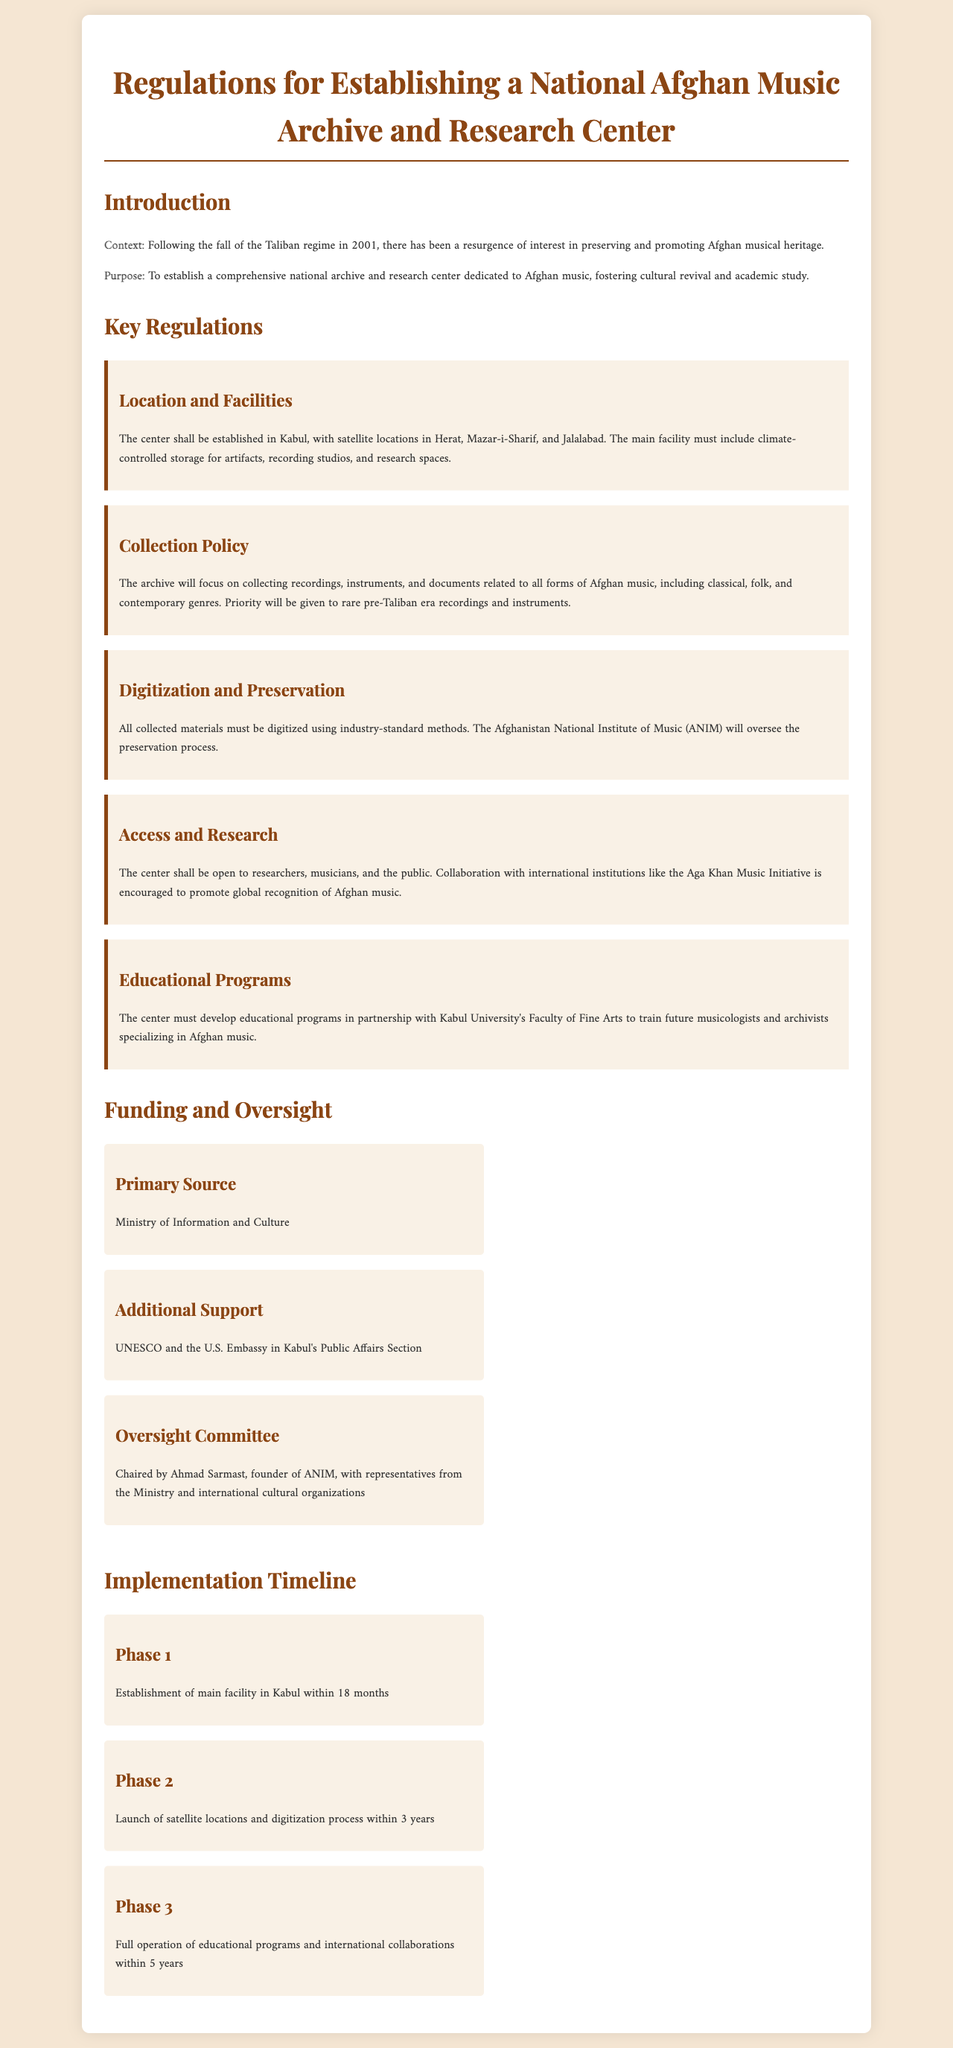What is the main location for the center? The main center will be established in Kabul, as stated in the key regulations section.
Answer: Kabul Which organization oversees the preservation process? The document specifies that the Afghanistan National Institute of Music (ANIM) will oversee preservation.
Answer: ANIM What is the priority for the collection policy? The document indicates that priority will be given to rare pre-Taliban era recordings and instruments.
Answer: Rare pre-Taliban era recordings and instruments Who is the chair of the oversight committee? The document clearly names Ahmad Sarmast as the chair of the oversight committee.
Answer: Ahmad Sarmast What is the time frame for establishing the main facility? The timeline section reveals that the main facility is to be established within 18 months.
Answer: 18 months Which entity is mentioned as a source of additional support? The document refers to UNESCO as one of the sources of additional support.
Answer: UNESCO What type of educational programs must the center develop? The educational programs must focus on training future musicologists and archivists specializing in Afghan music.
Answer: Musicologists and archivists What is the goal of international collaboration mentioned in the document? The collaboration aims to promote global recognition of Afghan music, as explained in the access and research section.
Answer: Global recognition of Afghan music What is the establishment phase called in the implementation timeline? The first phase mentioned in the document is simply called Phase 1.
Answer: Phase 1 